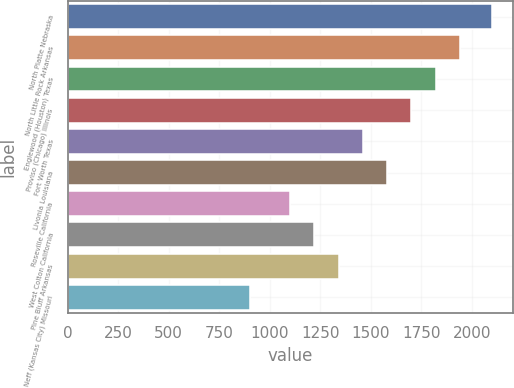Convert chart to OTSL. <chart><loc_0><loc_0><loc_500><loc_500><bar_chart><fcel>North Platte Nebraska<fcel>North Little Rock Arkansas<fcel>Englewood (Houston) Texas<fcel>Proviso (Chicago) Illinois<fcel>Fort Worth Texas<fcel>Livonia Louisiana<fcel>Roseville California<fcel>West Colton California<fcel>Pine Bluff Arkansas<fcel>Neff (Kansas City) Missouri<nl><fcel>2100<fcel>1940<fcel>1820<fcel>1700<fcel>1460<fcel>1580<fcel>1100<fcel>1220<fcel>1340<fcel>900<nl></chart> 